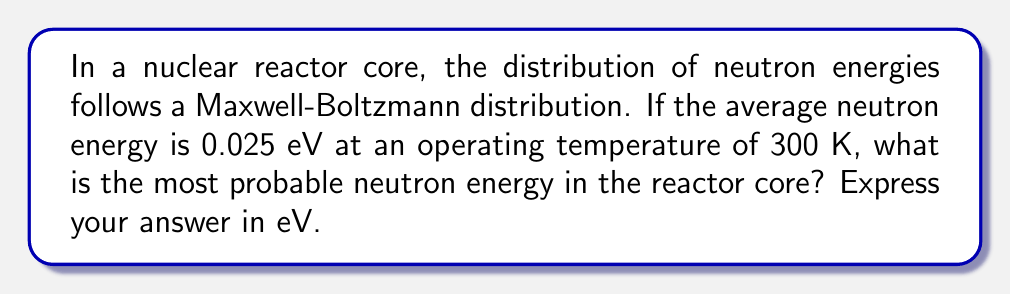Can you answer this question? To solve this problem, we'll follow these steps:

1) The Maxwell-Boltzmann distribution for neutron energies in a reactor is given by:

   $$f(E) = \frac{2}{\sqrt{\pi}}\left(\frac{E}{(kT)^3}\right)^{1/2} e^{-E/kT}$$

   where $E$ is the neutron energy, $k$ is the Boltzmann constant, and $T$ is the temperature.

2) The average energy $\langle E \rangle$ in a Maxwell-Boltzmann distribution is related to $kT$ by:

   $$\langle E \rangle = \frac{3}{2}kT$$

3) Given that $\langle E \rangle = 0.025$ eV, we can find $kT$:

   $$0.025 \text{ eV} = \frac{3}{2}kT$$
   $$kT = \frac{2}{3} \times 0.025 \text{ eV} = 0.0167 \text{ eV}$$

4) The most probable energy $E_p$ in a Maxwell-Boltzmann distribution is related to $kT$ by:

   $$E_p = \frac{1}{2}kT$$

5) Substituting the value of $kT$ we found:

   $$E_p = \frac{1}{2} \times 0.0167 \text{ eV} = 0.00835 \text{ eV}$$

Thus, the most probable neutron energy in the reactor core is 0.00835 eV.
Answer: 0.00835 eV 